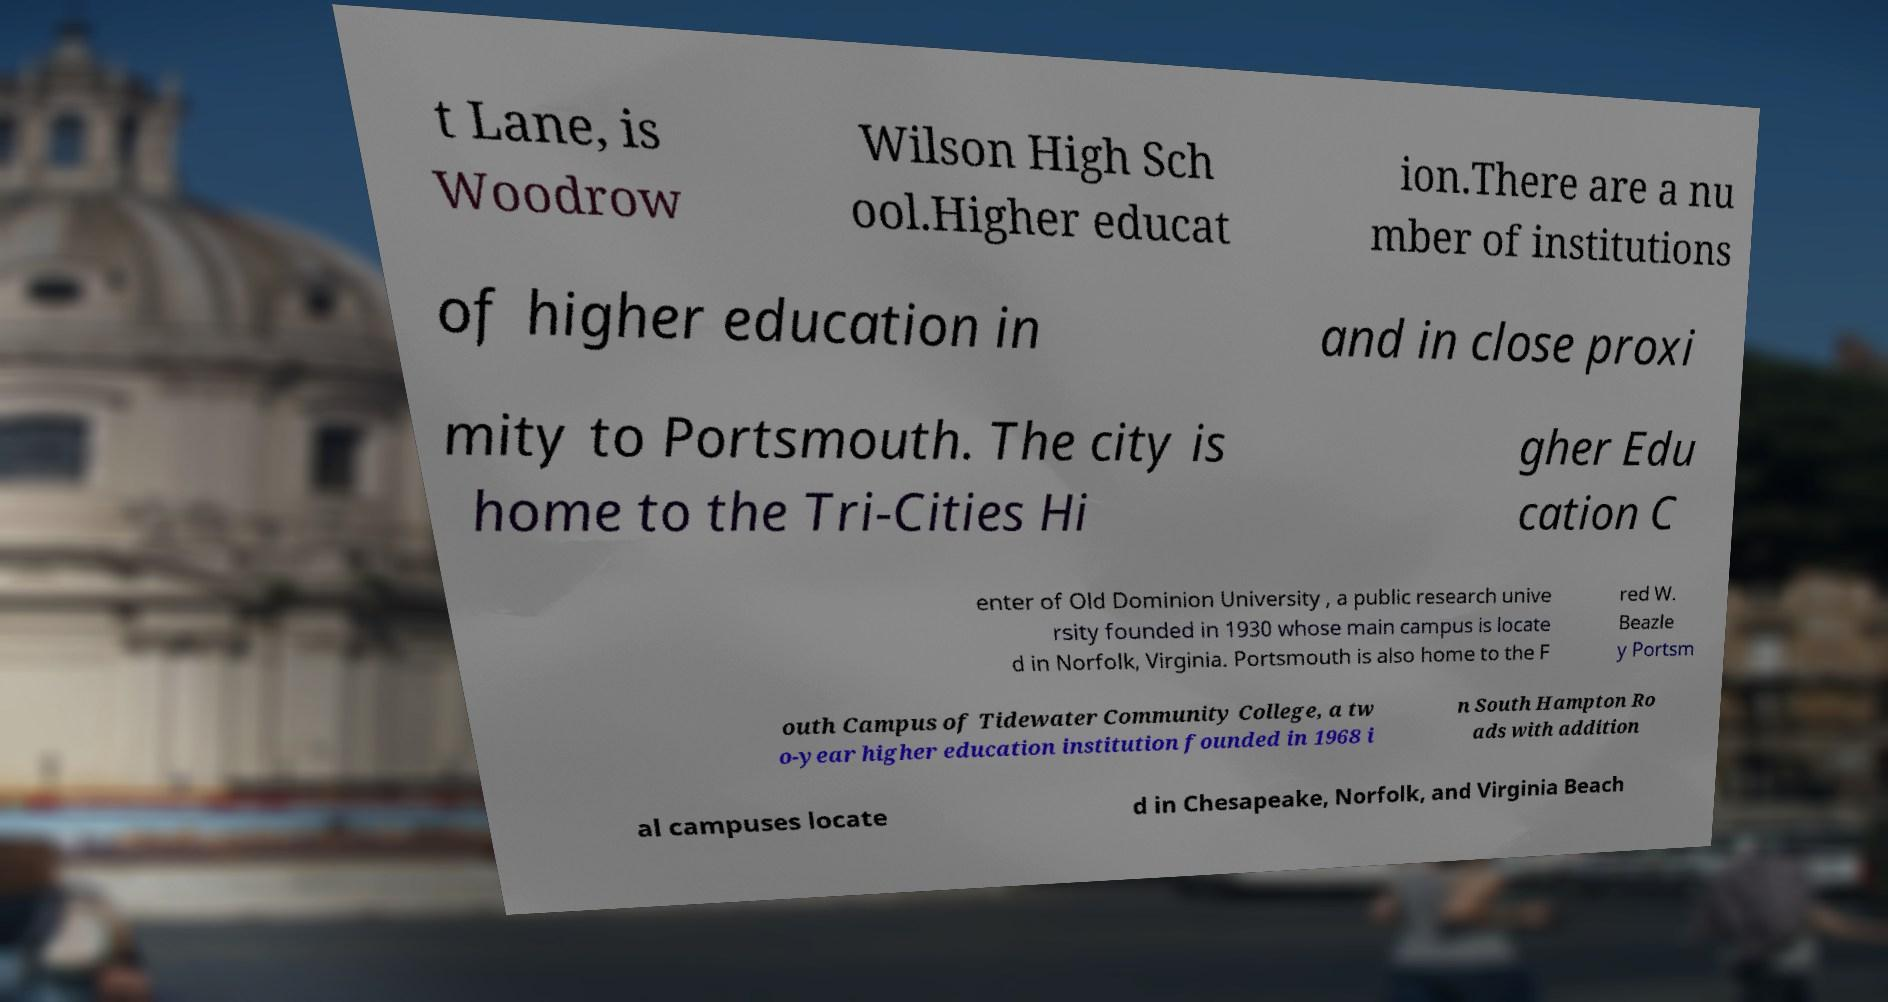Can you read and provide the text displayed in the image?This photo seems to have some interesting text. Can you extract and type it out for me? t Lane, is Woodrow Wilson High Sch ool.Higher educat ion.There are a nu mber of institutions of higher education in and in close proxi mity to Portsmouth. The city is home to the Tri-Cities Hi gher Edu cation C enter of Old Dominion University , a public research unive rsity founded in 1930 whose main campus is locate d in Norfolk, Virginia. Portsmouth is also home to the F red W. Beazle y Portsm outh Campus of Tidewater Community College, a tw o-year higher education institution founded in 1968 i n South Hampton Ro ads with addition al campuses locate d in Chesapeake, Norfolk, and Virginia Beach 